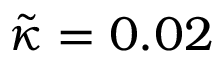<formula> <loc_0><loc_0><loc_500><loc_500>\tilde { \kappa } = 0 . 0 2</formula> 